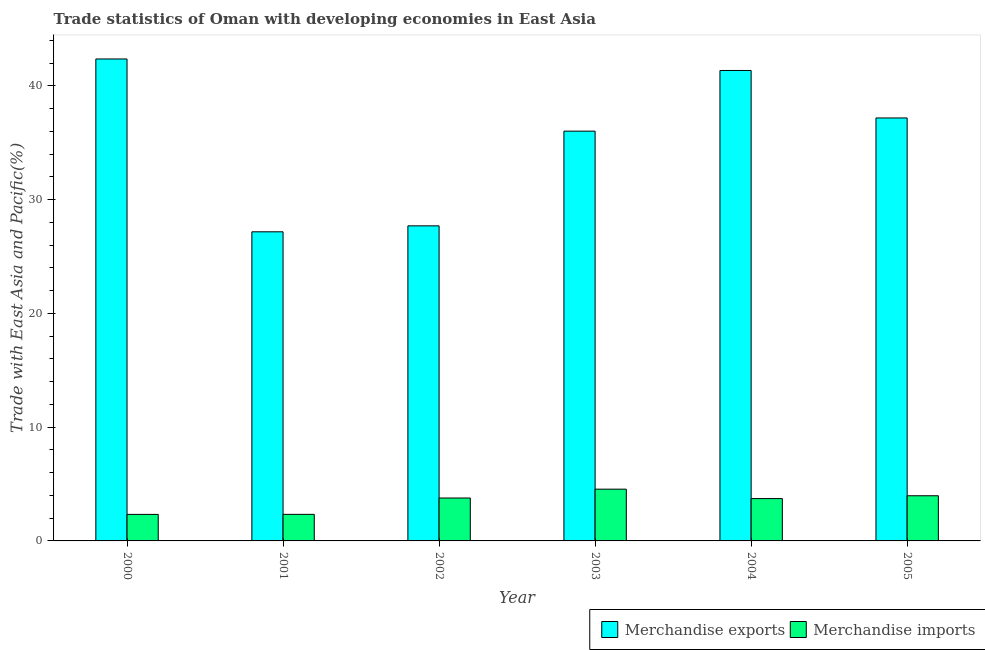How many different coloured bars are there?
Provide a succinct answer. 2. Are the number of bars per tick equal to the number of legend labels?
Your answer should be compact. Yes. Are the number of bars on each tick of the X-axis equal?
Your response must be concise. Yes. How many bars are there on the 5th tick from the left?
Your response must be concise. 2. How many bars are there on the 2nd tick from the right?
Your answer should be very brief. 2. In how many cases, is the number of bars for a given year not equal to the number of legend labels?
Keep it short and to the point. 0. What is the merchandise exports in 2001?
Provide a succinct answer. 27.18. Across all years, what is the maximum merchandise imports?
Give a very brief answer. 4.55. Across all years, what is the minimum merchandise exports?
Give a very brief answer. 27.18. In which year was the merchandise imports maximum?
Provide a succinct answer. 2003. What is the total merchandise imports in the graph?
Offer a terse response. 20.69. What is the difference between the merchandise exports in 2001 and that in 2003?
Ensure brevity in your answer.  -8.85. What is the difference between the merchandise imports in 2000 and the merchandise exports in 2004?
Provide a succinct answer. -1.39. What is the average merchandise imports per year?
Offer a terse response. 3.45. In the year 2000, what is the difference between the merchandise exports and merchandise imports?
Give a very brief answer. 0. What is the ratio of the merchandise imports in 2001 to that in 2002?
Make the answer very short. 0.62. Is the merchandise imports in 2000 less than that in 2003?
Your response must be concise. Yes. Is the difference between the merchandise exports in 2000 and 2001 greater than the difference between the merchandise imports in 2000 and 2001?
Make the answer very short. No. What is the difference between the highest and the second highest merchandise exports?
Your answer should be compact. 1.01. What is the difference between the highest and the lowest merchandise exports?
Your answer should be compact. 15.2. Is the sum of the merchandise exports in 2002 and 2004 greater than the maximum merchandise imports across all years?
Your answer should be compact. Yes. How many bars are there?
Keep it short and to the point. 12. How many years are there in the graph?
Provide a short and direct response. 6. What is the difference between two consecutive major ticks on the Y-axis?
Your response must be concise. 10. Are the values on the major ticks of Y-axis written in scientific E-notation?
Your response must be concise. No. Does the graph contain any zero values?
Provide a succinct answer. No. Does the graph contain grids?
Make the answer very short. No. How many legend labels are there?
Provide a short and direct response. 2. What is the title of the graph?
Provide a succinct answer. Trade statistics of Oman with developing economies in East Asia. What is the label or title of the X-axis?
Provide a succinct answer. Year. What is the label or title of the Y-axis?
Your answer should be very brief. Trade with East Asia and Pacific(%). What is the Trade with East Asia and Pacific(%) of Merchandise exports in 2000?
Your response must be concise. 42.37. What is the Trade with East Asia and Pacific(%) in Merchandise imports in 2000?
Make the answer very short. 2.33. What is the Trade with East Asia and Pacific(%) of Merchandise exports in 2001?
Offer a terse response. 27.18. What is the Trade with East Asia and Pacific(%) of Merchandise imports in 2001?
Ensure brevity in your answer.  2.34. What is the Trade with East Asia and Pacific(%) of Merchandise exports in 2002?
Make the answer very short. 27.7. What is the Trade with East Asia and Pacific(%) of Merchandise imports in 2002?
Offer a terse response. 3.77. What is the Trade with East Asia and Pacific(%) of Merchandise exports in 2003?
Your answer should be very brief. 36.03. What is the Trade with East Asia and Pacific(%) in Merchandise imports in 2003?
Provide a short and direct response. 4.55. What is the Trade with East Asia and Pacific(%) in Merchandise exports in 2004?
Your answer should be very brief. 41.36. What is the Trade with East Asia and Pacific(%) in Merchandise imports in 2004?
Provide a short and direct response. 3.72. What is the Trade with East Asia and Pacific(%) of Merchandise exports in 2005?
Your response must be concise. 37.19. What is the Trade with East Asia and Pacific(%) in Merchandise imports in 2005?
Offer a very short reply. 3.97. Across all years, what is the maximum Trade with East Asia and Pacific(%) in Merchandise exports?
Give a very brief answer. 42.37. Across all years, what is the maximum Trade with East Asia and Pacific(%) in Merchandise imports?
Provide a short and direct response. 4.55. Across all years, what is the minimum Trade with East Asia and Pacific(%) of Merchandise exports?
Your response must be concise. 27.18. Across all years, what is the minimum Trade with East Asia and Pacific(%) in Merchandise imports?
Keep it short and to the point. 2.33. What is the total Trade with East Asia and Pacific(%) of Merchandise exports in the graph?
Give a very brief answer. 211.83. What is the total Trade with East Asia and Pacific(%) in Merchandise imports in the graph?
Your answer should be compact. 20.69. What is the difference between the Trade with East Asia and Pacific(%) in Merchandise exports in 2000 and that in 2001?
Make the answer very short. 15.2. What is the difference between the Trade with East Asia and Pacific(%) of Merchandise imports in 2000 and that in 2001?
Provide a short and direct response. -0. What is the difference between the Trade with East Asia and Pacific(%) in Merchandise exports in 2000 and that in 2002?
Provide a succinct answer. 14.67. What is the difference between the Trade with East Asia and Pacific(%) of Merchandise imports in 2000 and that in 2002?
Your response must be concise. -1.44. What is the difference between the Trade with East Asia and Pacific(%) in Merchandise exports in 2000 and that in 2003?
Make the answer very short. 6.35. What is the difference between the Trade with East Asia and Pacific(%) of Merchandise imports in 2000 and that in 2003?
Provide a succinct answer. -2.22. What is the difference between the Trade with East Asia and Pacific(%) in Merchandise exports in 2000 and that in 2004?
Your answer should be compact. 1.01. What is the difference between the Trade with East Asia and Pacific(%) of Merchandise imports in 2000 and that in 2004?
Provide a succinct answer. -1.39. What is the difference between the Trade with East Asia and Pacific(%) of Merchandise exports in 2000 and that in 2005?
Your answer should be very brief. 5.19. What is the difference between the Trade with East Asia and Pacific(%) of Merchandise imports in 2000 and that in 2005?
Your answer should be very brief. -1.64. What is the difference between the Trade with East Asia and Pacific(%) of Merchandise exports in 2001 and that in 2002?
Ensure brevity in your answer.  -0.52. What is the difference between the Trade with East Asia and Pacific(%) of Merchandise imports in 2001 and that in 2002?
Your response must be concise. -1.44. What is the difference between the Trade with East Asia and Pacific(%) in Merchandise exports in 2001 and that in 2003?
Give a very brief answer. -8.85. What is the difference between the Trade with East Asia and Pacific(%) in Merchandise imports in 2001 and that in 2003?
Offer a very short reply. -2.21. What is the difference between the Trade with East Asia and Pacific(%) in Merchandise exports in 2001 and that in 2004?
Your answer should be very brief. -14.18. What is the difference between the Trade with East Asia and Pacific(%) of Merchandise imports in 2001 and that in 2004?
Make the answer very short. -1.39. What is the difference between the Trade with East Asia and Pacific(%) of Merchandise exports in 2001 and that in 2005?
Offer a very short reply. -10.01. What is the difference between the Trade with East Asia and Pacific(%) in Merchandise imports in 2001 and that in 2005?
Offer a terse response. -1.63. What is the difference between the Trade with East Asia and Pacific(%) in Merchandise exports in 2002 and that in 2003?
Make the answer very short. -8.33. What is the difference between the Trade with East Asia and Pacific(%) of Merchandise imports in 2002 and that in 2003?
Offer a terse response. -0.78. What is the difference between the Trade with East Asia and Pacific(%) in Merchandise exports in 2002 and that in 2004?
Keep it short and to the point. -13.66. What is the difference between the Trade with East Asia and Pacific(%) in Merchandise imports in 2002 and that in 2004?
Make the answer very short. 0.05. What is the difference between the Trade with East Asia and Pacific(%) in Merchandise exports in 2002 and that in 2005?
Your answer should be compact. -9.49. What is the difference between the Trade with East Asia and Pacific(%) in Merchandise imports in 2002 and that in 2005?
Give a very brief answer. -0.2. What is the difference between the Trade with East Asia and Pacific(%) of Merchandise exports in 2003 and that in 2004?
Offer a terse response. -5.34. What is the difference between the Trade with East Asia and Pacific(%) in Merchandise imports in 2003 and that in 2004?
Provide a short and direct response. 0.83. What is the difference between the Trade with East Asia and Pacific(%) of Merchandise exports in 2003 and that in 2005?
Make the answer very short. -1.16. What is the difference between the Trade with East Asia and Pacific(%) of Merchandise imports in 2003 and that in 2005?
Ensure brevity in your answer.  0.58. What is the difference between the Trade with East Asia and Pacific(%) of Merchandise exports in 2004 and that in 2005?
Provide a short and direct response. 4.18. What is the difference between the Trade with East Asia and Pacific(%) of Merchandise imports in 2004 and that in 2005?
Offer a terse response. -0.25. What is the difference between the Trade with East Asia and Pacific(%) in Merchandise exports in 2000 and the Trade with East Asia and Pacific(%) in Merchandise imports in 2001?
Give a very brief answer. 40.04. What is the difference between the Trade with East Asia and Pacific(%) in Merchandise exports in 2000 and the Trade with East Asia and Pacific(%) in Merchandise imports in 2002?
Your answer should be very brief. 38.6. What is the difference between the Trade with East Asia and Pacific(%) of Merchandise exports in 2000 and the Trade with East Asia and Pacific(%) of Merchandise imports in 2003?
Give a very brief answer. 37.82. What is the difference between the Trade with East Asia and Pacific(%) of Merchandise exports in 2000 and the Trade with East Asia and Pacific(%) of Merchandise imports in 2004?
Keep it short and to the point. 38.65. What is the difference between the Trade with East Asia and Pacific(%) in Merchandise exports in 2000 and the Trade with East Asia and Pacific(%) in Merchandise imports in 2005?
Make the answer very short. 38.4. What is the difference between the Trade with East Asia and Pacific(%) in Merchandise exports in 2001 and the Trade with East Asia and Pacific(%) in Merchandise imports in 2002?
Your answer should be compact. 23.4. What is the difference between the Trade with East Asia and Pacific(%) in Merchandise exports in 2001 and the Trade with East Asia and Pacific(%) in Merchandise imports in 2003?
Your answer should be very brief. 22.63. What is the difference between the Trade with East Asia and Pacific(%) in Merchandise exports in 2001 and the Trade with East Asia and Pacific(%) in Merchandise imports in 2004?
Your response must be concise. 23.46. What is the difference between the Trade with East Asia and Pacific(%) in Merchandise exports in 2001 and the Trade with East Asia and Pacific(%) in Merchandise imports in 2005?
Provide a short and direct response. 23.21. What is the difference between the Trade with East Asia and Pacific(%) of Merchandise exports in 2002 and the Trade with East Asia and Pacific(%) of Merchandise imports in 2003?
Keep it short and to the point. 23.15. What is the difference between the Trade with East Asia and Pacific(%) of Merchandise exports in 2002 and the Trade with East Asia and Pacific(%) of Merchandise imports in 2004?
Offer a very short reply. 23.98. What is the difference between the Trade with East Asia and Pacific(%) of Merchandise exports in 2002 and the Trade with East Asia and Pacific(%) of Merchandise imports in 2005?
Provide a succinct answer. 23.73. What is the difference between the Trade with East Asia and Pacific(%) of Merchandise exports in 2003 and the Trade with East Asia and Pacific(%) of Merchandise imports in 2004?
Ensure brevity in your answer.  32.3. What is the difference between the Trade with East Asia and Pacific(%) in Merchandise exports in 2003 and the Trade with East Asia and Pacific(%) in Merchandise imports in 2005?
Give a very brief answer. 32.06. What is the difference between the Trade with East Asia and Pacific(%) of Merchandise exports in 2004 and the Trade with East Asia and Pacific(%) of Merchandise imports in 2005?
Offer a terse response. 37.39. What is the average Trade with East Asia and Pacific(%) in Merchandise exports per year?
Your answer should be very brief. 35.3. What is the average Trade with East Asia and Pacific(%) in Merchandise imports per year?
Offer a very short reply. 3.45. In the year 2000, what is the difference between the Trade with East Asia and Pacific(%) in Merchandise exports and Trade with East Asia and Pacific(%) in Merchandise imports?
Provide a succinct answer. 40.04. In the year 2001, what is the difference between the Trade with East Asia and Pacific(%) of Merchandise exports and Trade with East Asia and Pacific(%) of Merchandise imports?
Your response must be concise. 24.84. In the year 2002, what is the difference between the Trade with East Asia and Pacific(%) in Merchandise exports and Trade with East Asia and Pacific(%) in Merchandise imports?
Provide a short and direct response. 23.93. In the year 2003, what is the difference between the Trade with East Asia and Pacific(%) of Merchandise exports and Trade with East Asia and Pacific(%) of Merchandise imports?
Provide a short and direct response. 31.48. In the year 2004, what is the difference between the Trade with East Asia and Pacific(%) in Merchandise exports and Trade with East Asia and Pacific(%) in Merchandise imports?
Ensure brevity in your answer.  37.64. In the year 2005, what is the difference between the Trade with East Asia and Pacific(%) of Merchandise exports and Trade with East Asia and Pacific(%) of Merchandise imports?
Your response must be concise. 33.22. What is the ratio of the Trade with East Asia and Pacific(%) in Merchandise exports in 2000 to that in 2001?
Offer a very short reply. 1.56. What is the ratio of the Trade with East Asia and Pacific(%) in Merchandise exports in 2000 to that in 2002?
Offer a terse response. 1.53. What is the ratio of the Trade with East Asia and Pacific(%) in Merchandise imports in 2000 to that in 2002?
Provide a succinct answer. 0.62. What is the ratio of the Trade with East Asia and Pacific(%) in Merchandise exports in 2000 to that in 2003?
Give a very brief answer. 1.18. What is the ratio of the Trade with East Asia and Pacific(%) in Merchandise imports in 2000 to that in 2003?
Provide a short and direct response. 0.51. What is the ratio of the Trade with East Asia and Pacific(%) in Merchandise exports in 2000 to that in 2004?
Keep it short and to the point. 1.02. What is the ratio of the Trade with East Asia and Pacific(%) in Merchandise imports in 2000 to that in 2004?
Offer a very short reply. 0.63. What is the ratio of the Trade with East Asia and Pacific(%) in Merchandise exports in 2000 to that in 2005?
Make the answer very short. 1.14. What is the ratio of the Trade with East Asia and Pacific(%) of Merchandise imports in 2000 to that in 2005?
Offer a terse response. 0.59. What is the ratio of the Trade with East Asia and Pacific(%) in Merchandise exports in 2001 to that in 2002?
Provide a succinct answer. 0.98. What is the ratio of the Trade with East Asia and Pacific(%) of Merchandise imports in 2001 to that in 2002?
Provide a succinct answer. 0.62. What is the ratio of the Trade with East Asia and Pacific(%) of Merchandise exports in 2001 to that in 2003?
Keep it short and to the point. 0.75. What is the ratio of the Trade with East Asia and Pacific(%) of Merchandise imports in 2001 to that in 2003?
Offer a terse response. 0.51. What is the ratio of the Trade with East Asia and Pacific(%) of Merchandise exports in 2001 to that in 2004?
Provide a succinct answer. 0.66. What is the ratio of the Trade with East Asia and Pacific(%) of Merchandise imports in 2001 to that in 2004?
Keep it short and to the point. 0.63. What is the ratio of the Trade with East Asia and Pacific(%) in Merchandise exports in 2001 to that in 2005?
Provide a short and direct response. 0.73. What is the ratio of the Trade with East Asia and Pacific(%) in Merchandise imports in 2001 to that in 2005?
Provide a short and direct response. 0.59. What is the ratio of the Trade with East Asia and Pacific(%) of Merchandise exports in 2002 to that in 2003?
Provide a succinct answer. 0.77. What is the ratio of the Trade with East Asia and Pacific(%) in Merchandise imports in 2002 to that in 2003?
Offer a terse response. 0.83. What is the ratio of the Trade with East Asia and Pacific(%) of Merchandise exports in 2002 to that in 2004?
Provide a succinct answer. 0.67. What is the ratio of the Trade with East Asia and Pacific(%) in Merchandise imports in 2002 to that in 2004?
Your answer should be very brief. 1.01. What is the ratio of the Trade with East Asia and Pacific(%) in Merchandise exports in 2002 to that in 2005?
Make the answer very short. 0.74. What is the ratio of the Trade with East Asia and Pacific(%) in Merchandise imports in 2002 to that in 2005?
Give a very brief answer. 0.95. What is the ratio of the Trade with East Asia and Pacific(%) of Merchandise exports in 2003 to that in 2004?
Make the answer very short. 0.87. What is the ratio of the Trade with East Asia and Pacific(%) of Merchandise imports in 2003 to that in 2004?
Your response must be concise. 1.22. What is the ratio of the Trade with East Asia and Pacific(%) of Merchandise exports in 2003 to that in 2005?
Provide a short and direct response. 0.97. What is the ratio of the Trade with East Asia and Pacific(%) of Merchandise imports in 2003 to that in 2005?
Offer a terse response. 1.15. What is the ratio of the Trade with East Asia and Pacific(%) of Merchandise exports in 2004 to that in 2005?
Your response must be concise. 1.11. What is the ratio of the Trade with East Asia and Pacific(%) in Merchandise imports in 2004 to that in 2005?
Your answer should be very brief. 0.94. What is the difference between the highest and the second highest Trade with East Asia and Pacific(%) of Merchandise exports?
Your answer should be very brief. 1.01. What is the difference between the highest and the second highest Trade with East Asia and Pacific(%) of Merchandise imports?
Ensure brevity in your answer.  0.58. What is the difference between the highest and the lowest Trade with East Asia and Pacific(%) of Merchandise exports?
Ensure brevity in your answer.  15.2. What is the difference between the highest and the lowest Trade with East Asia and Pacific(%) of Merchandise imports?
Your answer should be compact. 2.22. 